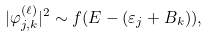Convert formula to latex. <formula><loc_0><loc_0><loc_500><loc_500>| \varphi ^ { ( \ell ) } _ { j , k } | ^ { 2 } \sim f ( E - ( \varepsilon _ { j } + B _ { k } ) ) ,</formula> 